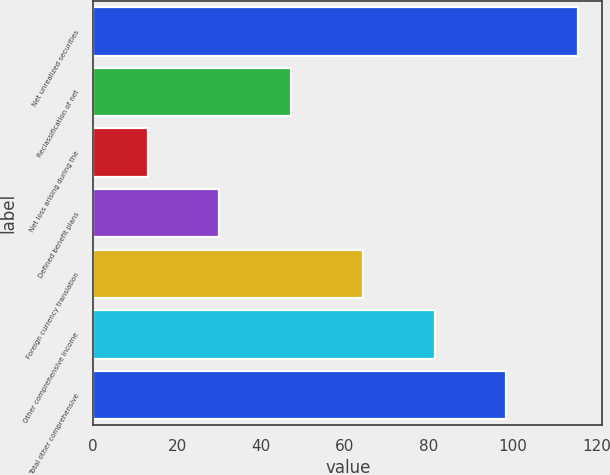<chart> <loc_0><loc_0><loc_500><loc_500><bar_chart><fcel>Net unrealized securities<fcel>Reclassification of net<fcel>Net loss arising during the<fcel>Defined benefit plans<fcel>Foreign currency translation<fcel>Other comprehensive income<fcel>Total other comprehensive<nl><fcel>115.6<fcel>47.2<fcel>13<fcel>30.1<fcel>64.3<fcel>81.4<fcel>98.5<nl></chart> 